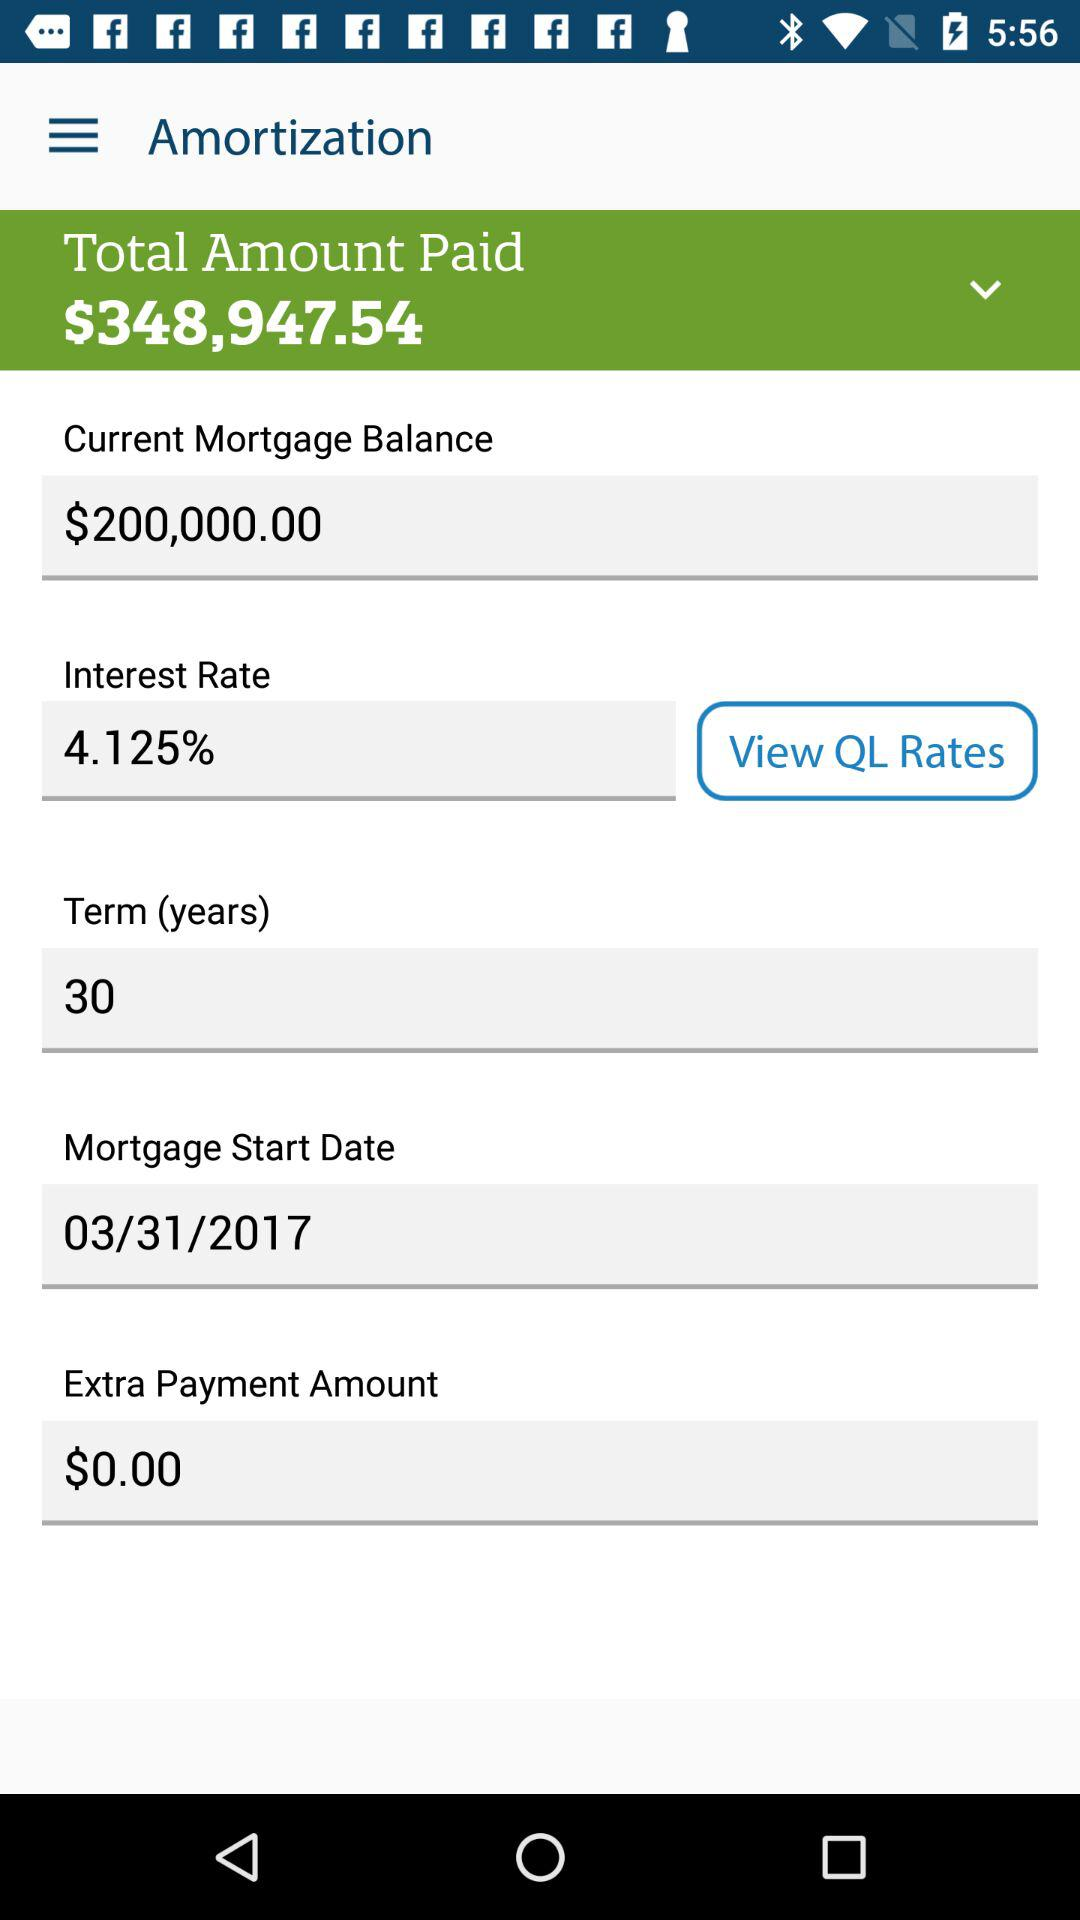What is the start date of the mortgage? The start date is March 31, 2017. 